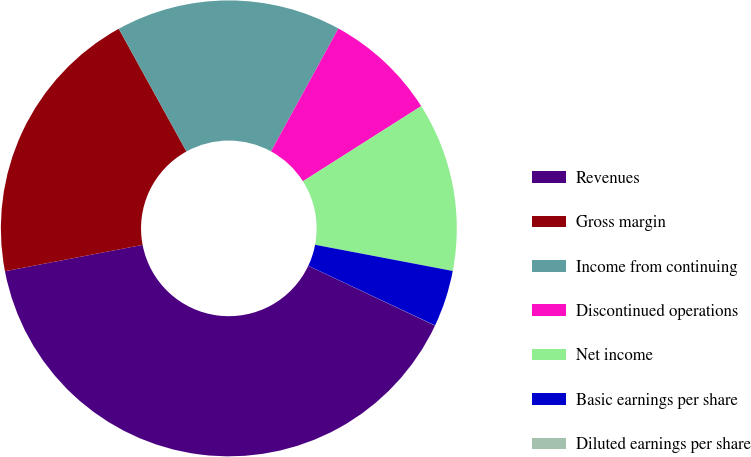Convert chart. <chart><loc_0><loc_0><loc_500><loc_500><pie_chart><fcel>Revenues<fcel>Gross margin<fcel>Income from continuing<fcel>Discontinued operations<fcel>Net income<fcel>Basic earnings per share<fcel>Diluted earnings per share<nl><fcel>39.98%<fcel>19.99%<fcel>16.0%<fcel>8.01%<fcel>12.0%<fcel>4.01%<fcel>0.01%<nl></chart> 